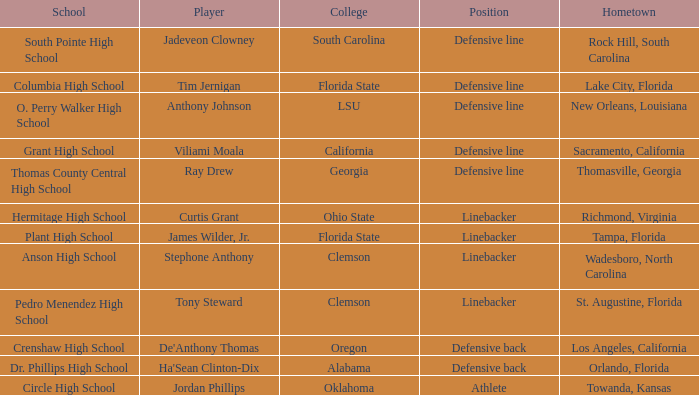In which hometown does a player of ray drew originate? Thomasville, Georgia. 